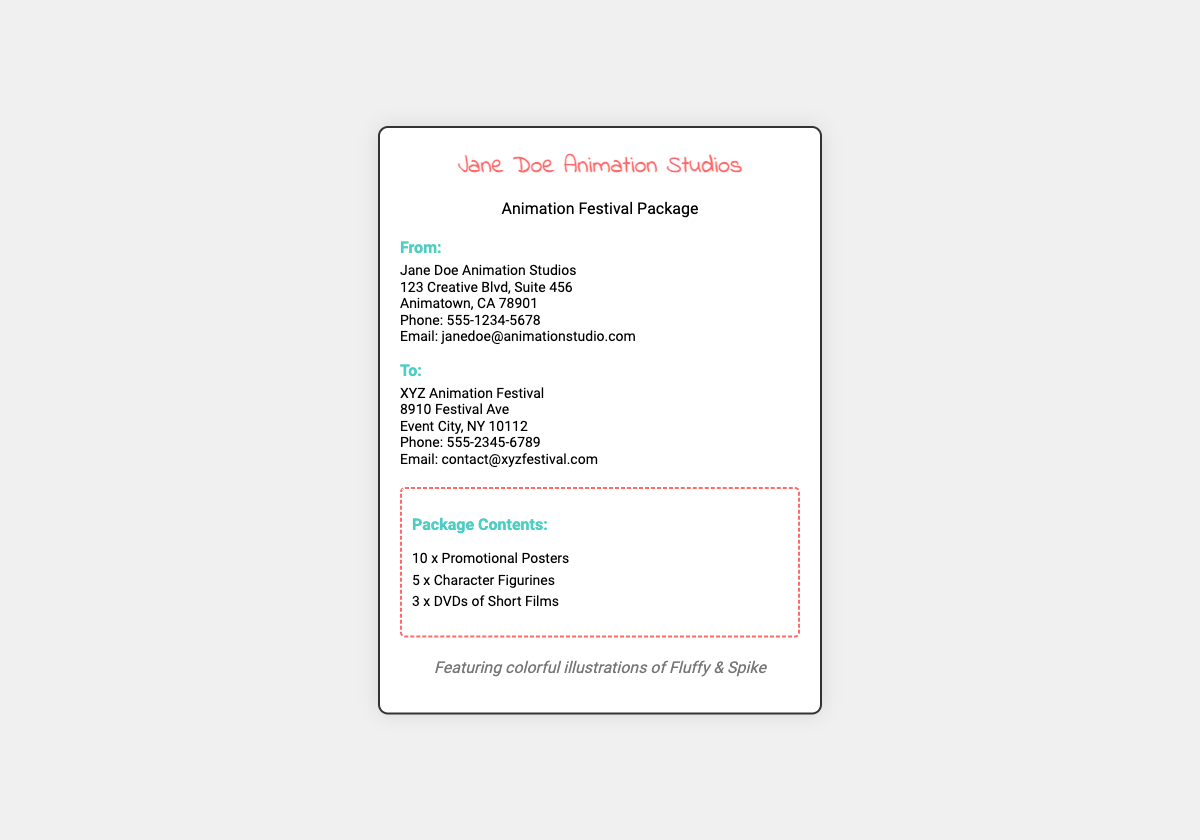What is the name of the studio? The studio name is displayed at the top of the label.
Answer: Jane Doe Animation Studios What is the package intended for? The heading "Animation Festival Package" indicates the purpose of the shipment.
Answer: Animation Festival Package How many promotional posters are included in the package? The contents section lists the number of promotional posters.
Answer: 10 What is the address of the sender? The sender's address is detailed under the "From" section.
Answer: 123 Creative Blvd, Suite 456, Animatown, CA 78901 Who is the recipient of the package? The "To" section identifies the recipient of the shipment.
Answer: XYZ Animation Festival What should the recipient do if they have questions? The contact information includes a phone number and email for inquiries.
Answer: 555-2345-6789 and contact@xyzfestival.com How many DVDs are included in the package? The contents list specifically mentions the number of DVDs.
Answer: 3 What is one of the artistic elements mentioned? The label describes artistic representations included in the document.
Answer: Colorful illustrations of Fluffy & Spike What type of items are included in the package? The contents section provides a list of items being shipped.
Answer: Promotional Posters, Character Figurines, DVDs 